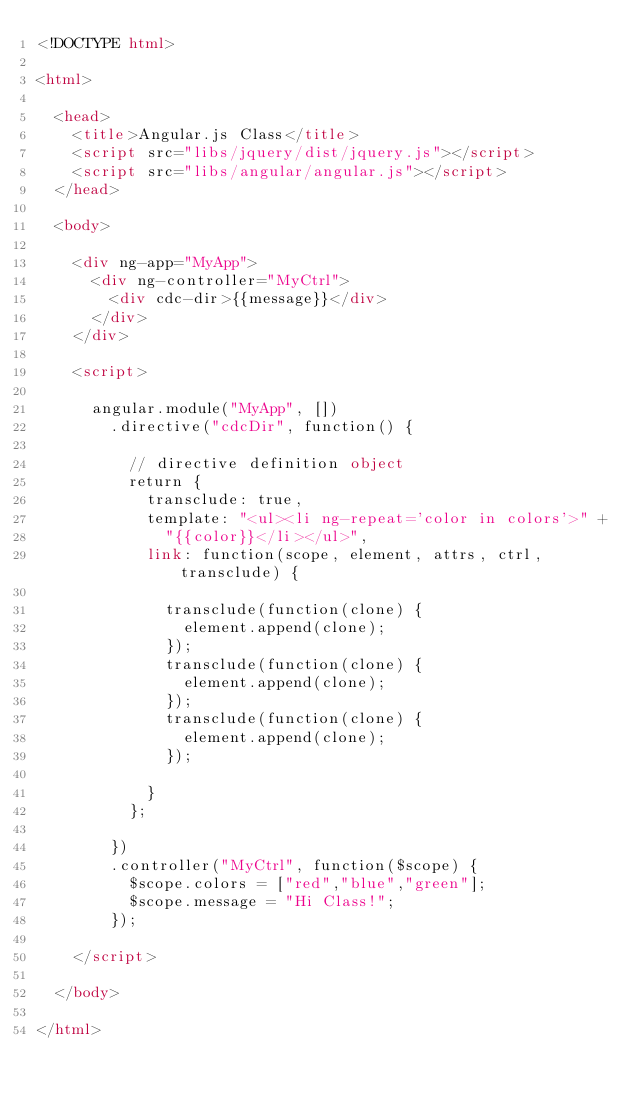Convert code to text. <code><loc_0><loc_0><loc_500><loc_500><_HTML_><!DOCTYPE html>

<html>

	<head>
		<title>Angular.js Class</title>
		<script src="libs/jquery/dist/jquery.js"></script>
		<script src="libs/angular/angular.js"></script>
	</head>

	<body>

		<div ng-app="MyApp">
			<div ng-controller="MyCtrl">
				<div cdc-dir>{{message}}</div>
			</div>
		</div>

		<script>

			angular.module("MyApp", [])
				.directive("cdcDir", function() {

					// directive definition object
					return {
						transclude: true,
						template: "<ul><li ng-repeat='color in colors'>" +
							"{{color}}</li></ul>",
						link: function(scope, element, attrs, ctrl, transclude) {

							transclude(function(clone) {
								element.append(clone);
							});
							transclude(function(clone) {
								element.append(clone);
							});
							transclude(function(clone) {
								element.append(clone);
							});

						}
					};

				})
				.controller("MyCtrl", function($scope) {
					$scope.colors = ["red","blue","green"];
					$scope.message = "Hi Class!";
				});

		</script>

	</body>

</html>
</code> 